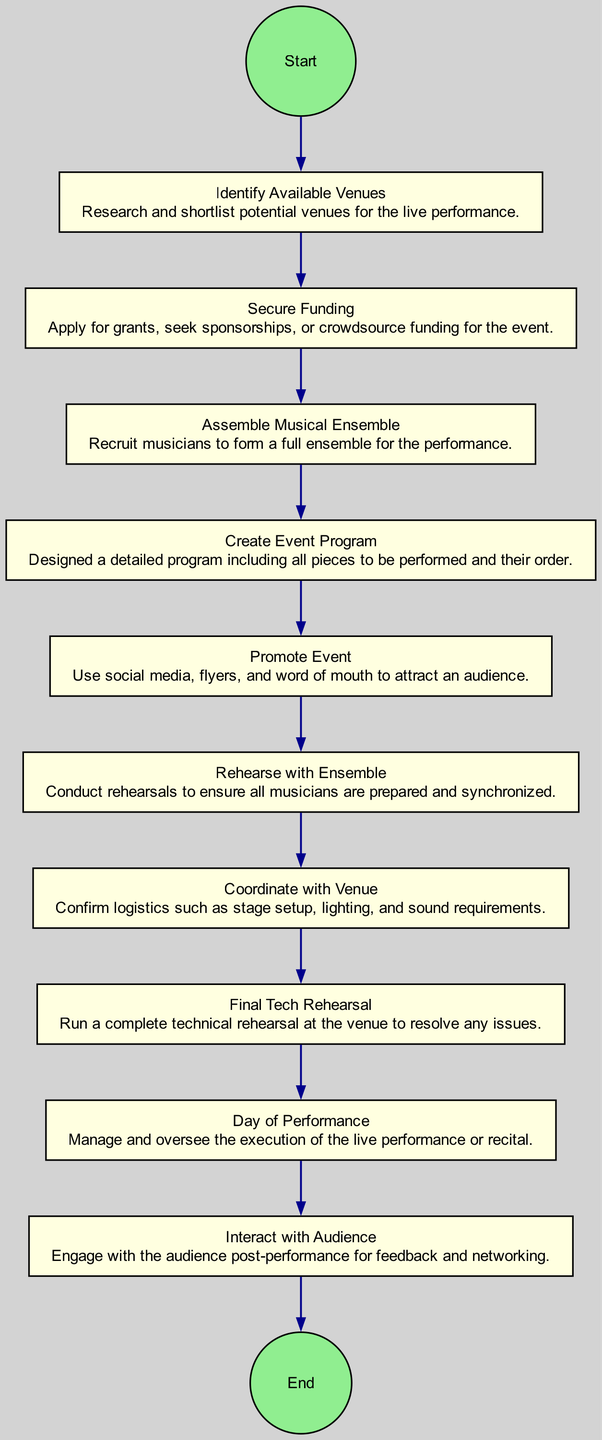What is the first step in the activity diagram? The first step is labeled "Identify Available Venues," which indicates that this is the initial action to take when organizing a live performance.
Answer: Identify Available Venues How many nodes are in the diagram? By counting the steps from the start node through to the end node, there are a total of ten nodes in the activity diagram.
Answer: Ten What is the last step before the performance day? The last step before "Day of Performance" is "Final Tech Rehearsal," indicating that it is the final preparation before the event.
Answer: Final Tech Rehearsal Which step involves engaging with the audience? The step labeled "Interact with Audience" involves engaging with the audience after the performance for feedback and networking purposes.
Answer: Interact with Audience Which two steps precede "Rehearse with Ensemble"? The steps "Assemble Musical Ensemble" and "Create Event Program" precede "Rehearse with Ensemble," indicating these actions must be completed first.
Answer: Assemble Musical Ensemble, Create Event Program What must be confirmed in the step "Coordinate with Venue"? The logistics that must be confirmed in this step include stage setup, lighting, and sound requirements for the event, ensuring all technical aspects are addressed.
Answer: Logistics In how many steps is audience promotion involved? The process of audience promotion is addressed in just one step, labeled "Promote Event," which outlines the actions taken to attract an audience.
Answer: One What is the main goal of the "Secure Funding" step? The main goal of "Secure Funding" is to obtain necessary financial resources for the event, through grants, sponsorships, or crowdfunding options.
Answer: Obtain financial resources What is the focus of the "Create Event Program" step? The focus of this step is on designing a detailed program that includes all pieces to be performed and their order, which is essential for both performers and the audience.
Answer: Designing a program 